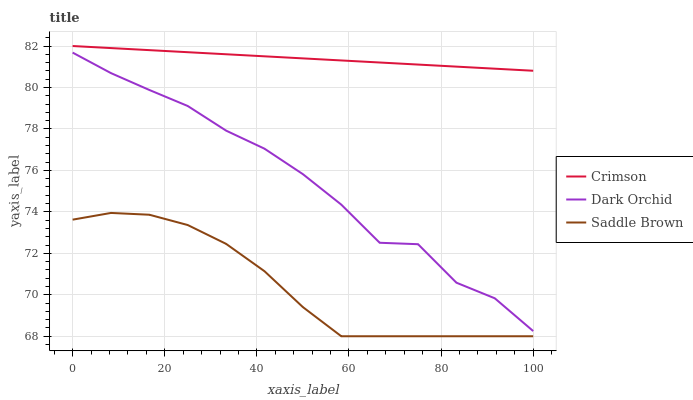Does Saddle Brown have the minimum area under the curve?
Answer yes or no. Yes. Does Crimson have the maximum area under the curve?
Answer yes or no. Yes. Does Dark Orchid have the minimum area under the curve?
Answer yes or no. No. Does Dark Orchid have the maximum area under the curve?
Answer yes or no. No. Is Crimson the smoothest?
Answer yes or no. Yes. Is Dark Orchid the roughest?
Answer yes or no. Yes. Is Saddle Brown the smoothest?
Answer yes or no. No. Is Saddle Brown the roughest?
Answer yes or no. No. Does Saddle Brown have the lowest value?
Answer yes or no. Yes. Does Dark Orchid have the lowest value?
Answer yes or no. No. Does Crimson have the highest value?
Answer yes or no. Yes. Does Dark Orchid have the highest value?
Answer yes or no. No. Is Saddle Brown less than Crimson?
Answer yes or no. Yes. Is Dark Orchid greater than Saddle Brown?
Answer yes or no. Yes. Does Saddle Brown intersect Crimson?
Answer yes or no. No. 